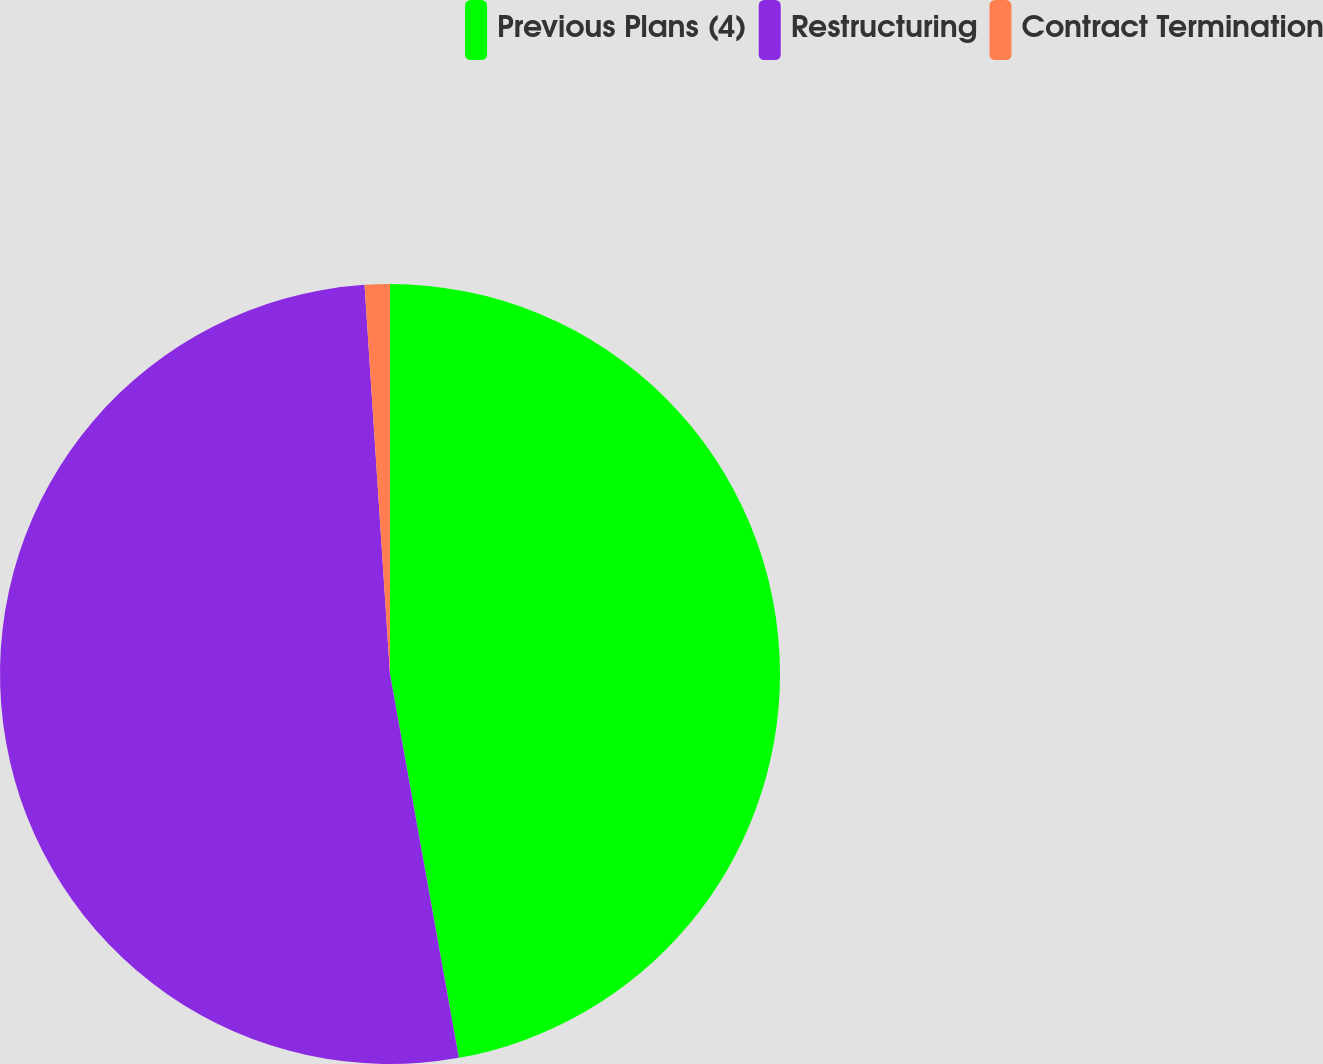Convert chart. <chart><loc_0><loc_0><loc_500><loc_500><pie_chart><fcel>Previous Plans (4)<fcel>Restructuring<fcel>Contract Termination<nl><fcel>47.18%<fcel>51.79%<fcel>1.04%<nl></chart> 